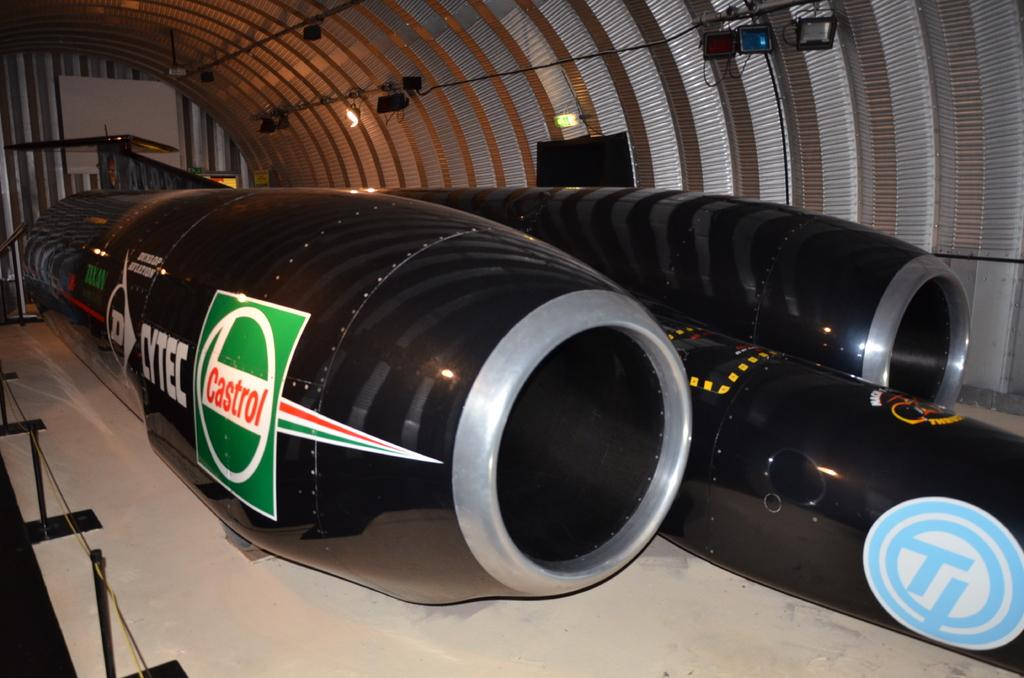<image>
Provide a brief description of the given image. Jet Engine of a rocket that says Castrol on the left side. 